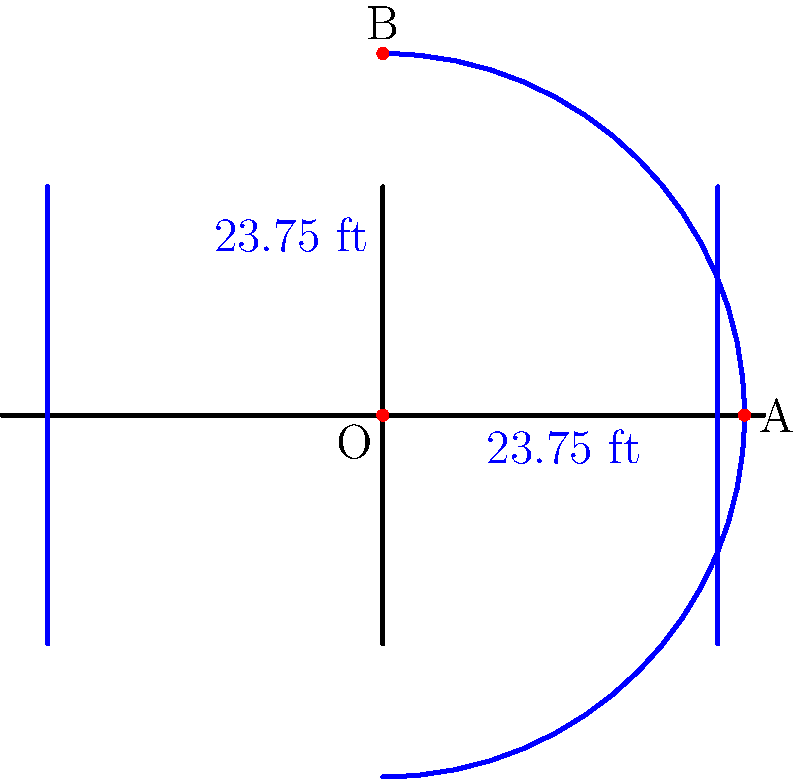Given that the three-point line on a basketball court forms a semicircle with a radius of 23.75 feet from the center of the basket, determine the equation of the circle that represents this three-point line. Assume the center of the basket is at the origin (0,0) and the court extends along the positive y-axis. To find the equation of the circle representing the three-point line, we'll follow these steps:

1) The general equation of a circle is:
   $$(x - h)^2 + (y - k)^2 = r^2$$
   where $(h,k)$ is the center of the circle and $r$ is the radius.

2) In this case:
   - The center of the circle is at (0,0), so $h = 0$ and $k = 0$
   - The radius is 23.75 feet

3) Substituting these values into the general equation:
   $$(x - 0)^2 + (y - 0)^2 = 23.75^2$$

4) Simplifying:
   $$x^2 + y^2 = 23.75^2$$

5) To get the final form, we need to calculate $23.75^2$:
   $$23.75^2 = 564.0625$$

6) Therefore, the equation of the circle is:
   $$x^2 + y^2 = 564.0625$$

This equation represents the full circle, but only the semicircle in the positive y-axis is used for the three-point line on the court.
Answer: $x^2 + y^2 = 564.0625$ 